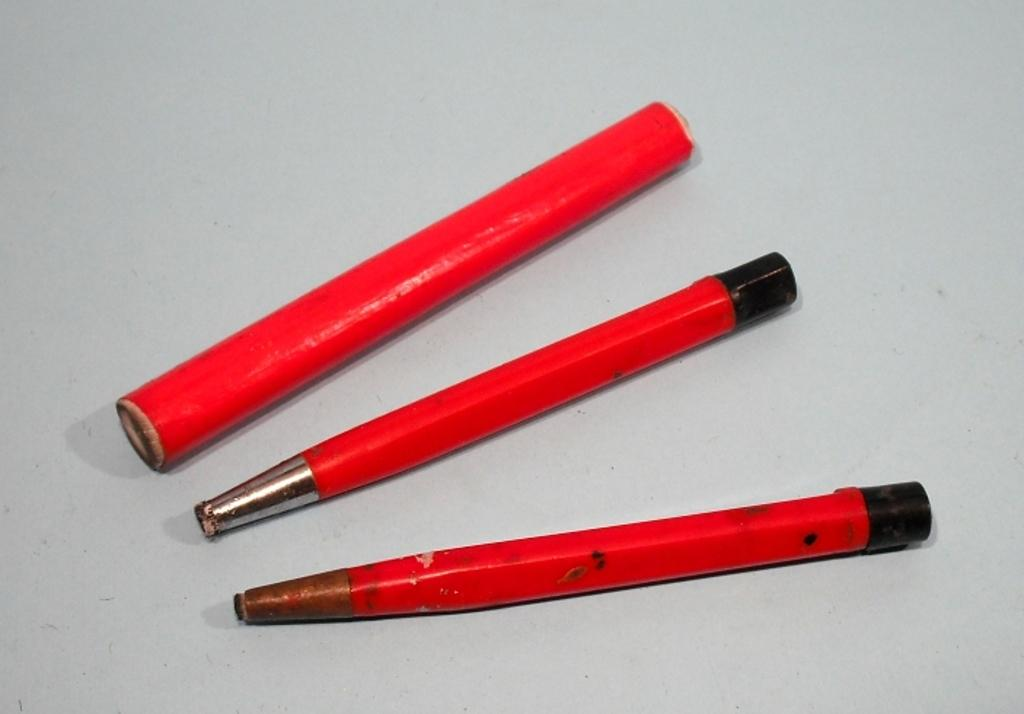How many objects are present in the image? There are three objects in the image. What is the color of the objects in the image? All three objects are red in color. What type of ornament is hanging from the ceiling in the image? There is no ornament hanging from the ceiling in the image; the facts only mention three red objects. How much sugar is present in the image? There is no mention of sugar in the image, as the facts only mention three red objects. 